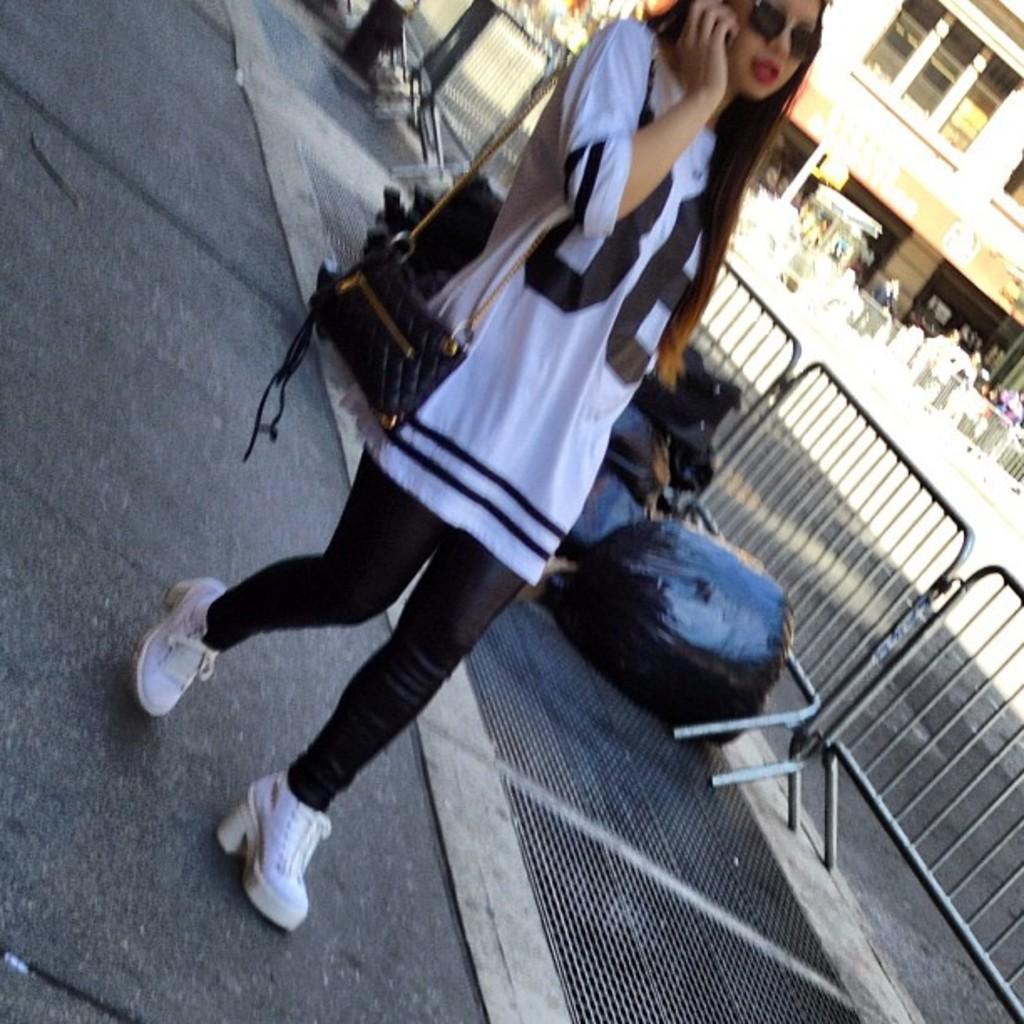Can you describe this image briefly? In this image there is a girl walking on the footpath by wearing the bag, behind her there are few plastic covers with some garbage in it are thrown on the footpath, Beside them there is a fence. In the background there is a building. Below the building there are few people standing on the road. At the top there is a bucket on the footpath. The woman is wearing the spectacles. 